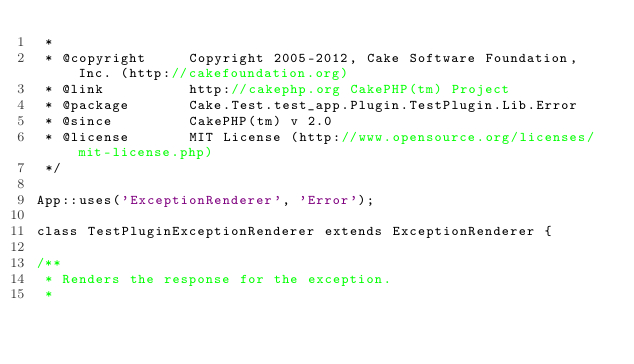<code> <loc_0><loc_0><loc_500><loc_500><_PHP_> *
 * @copyright     Copyright 2005-2012, Cake Software Foundation, Inc. (http://cakefoundation.org)
 * @link          http://cakephp.org CakePHP(tm) Project
 * @package       Cake.Test.test_app.Plugin.TestPlugin.Lib.Error
 * @since         CakePHP(tm) v 2.0
 * @license       MIT License (http://www.opensource.org/licenses/mit-license.php)
 */

App::uses('ExceptionRenderer', 'Error');

class TestPluginExceptionRenderer extends ExceptionRenderer {

/**
 * Renders the response for the exception.
 *</code> 